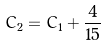<formula> <loc_0><loc_0><loc_500><loc_500>C _ { 2 } = C _ { 1 } + \frac { 4 } { 1 5 }</formula> 